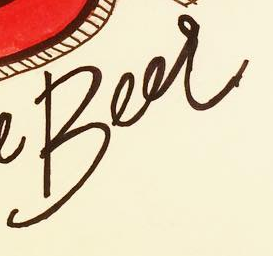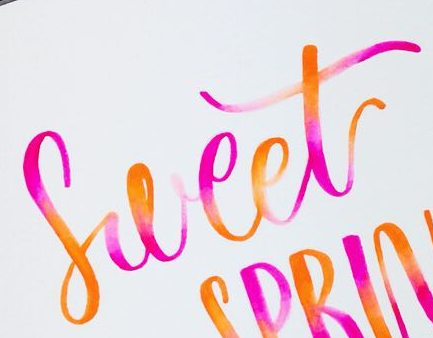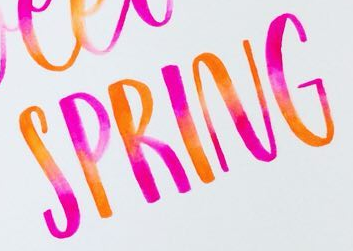What words are shown in these images in order, separated by a semicolon? Beer; Sweet; SPRING 